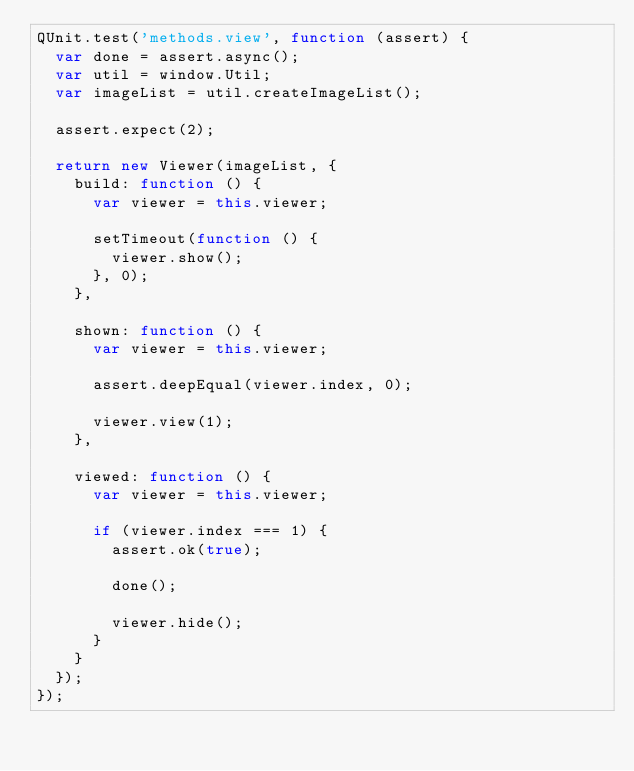Convert code to text. <code><loc_0><loc_0><loc_500><loc_500><_JavaScript_>QUnit.test('methods.view', function (assert) {
  var done = assert.async();
  var util = window.Util;
  var imageList = util.createImageList();

  assert.expect(2);

  return new Viewer(imageList, {
    build: function () {
      var viewer = this.viewer;

      setTimeout(function () {
        viewer.show();
      }, 0);
    },

    shown: function () {
      var viewer = this.viewer;

      assert.deepEqual(viewer.index, 0);

      viewer.view(1);
    },

    viewed: function () {
      var viewer = this.viewer;

      if (viewer.index === 1) {
        assert.ok(true);

        done();

        viewer.hide();
      }
    }
  });
});
</code> 